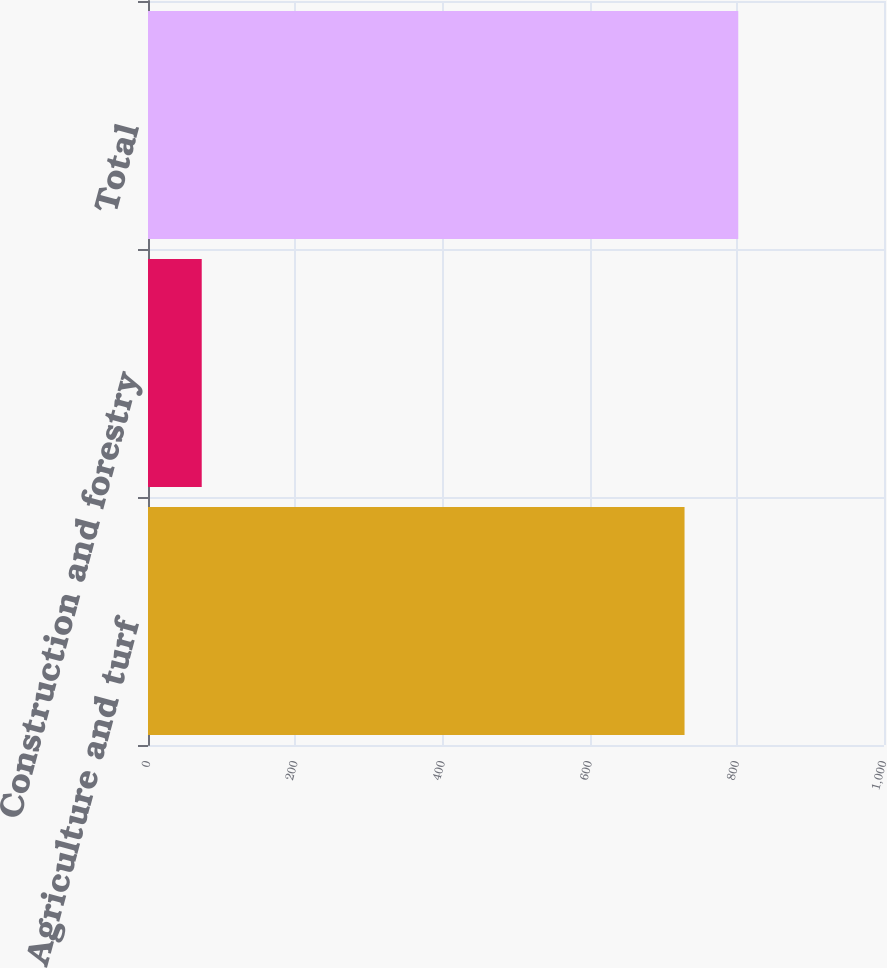Convert chart to OTSL. <chart><loc_0><loc_0><loc_500><loc_500><bar_chart><fcel>Agriculture and turf<fcel>Construction and forestry<fcel>Total<nl><fcel>729<fcel>73<fcel>802<nl></chart> 